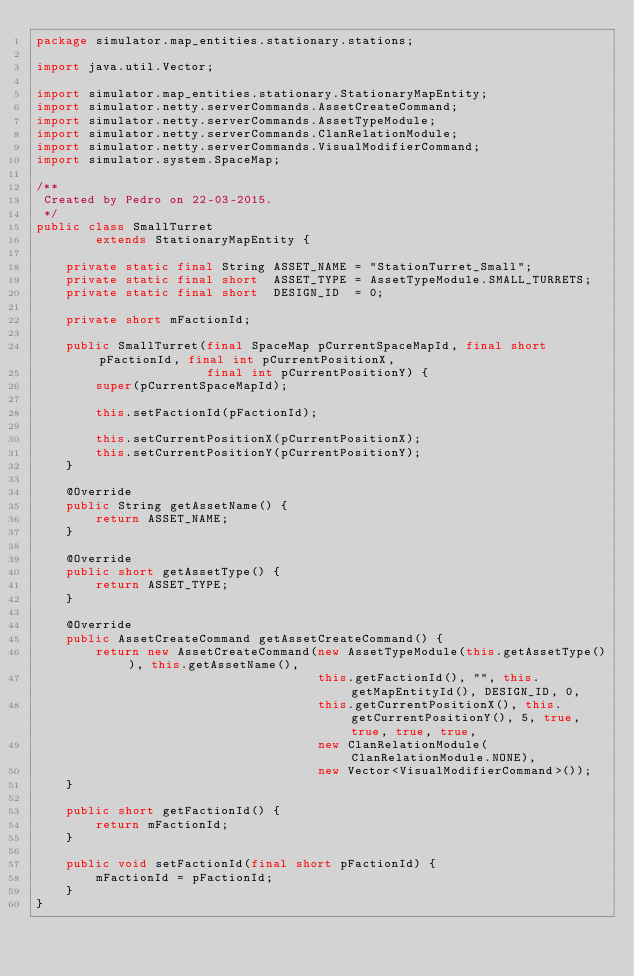<code> <loc_0><loc_0><loc_500><loc_500><_Java_>package simulator.map_entities.stationary.stations;

import java.util.Vector;

import simulator.map_entities.stationary.StationaryMapEntity;
import simulator.netty.serverCommands.AssetCreateCommand;
import simulator.netty.serverCommands.AssetTypeModule;
import simulator.netty.serverCommands.ClanRelationModule;
import simulator.netty.serverCommands.VisualModifierCommand;
import simulator.system.SpaceMap;

/**
 Created by Pedro on 22-03-2015.
 */
public class SmallTurret
        extends StationaryMapEntity {

    private static final String ASSET_NAME = "StationTurret_Small";
    private static final short  ASSET_TYPE = AssetTypeModule.SMALL_TURRETS;
    private static final short  DESIGN_ID  = 0;

    private short mFactionId;

    public SmallTurret(final SpaceMap pCurrentSpaceMapId, final short pFactionId, final int pCurrentPositionX,
                       final int pCurrentPositionY) {
        super(pCurrentSpaceMapId);

        this.setFactionId(pFactionId);

        this.setCurrentPositionX(pCurrentPositionX);
        this.setCurrentPositionY(pCurrentPositionY);
    }

    @Override
    public String getAssetName() {
        return ASSET_NAME;
    }

    @Override
    public short getAssetType() {
        return ASSET_TYPE;
    }

    @Override
    public AssetCreateCommand getAssetCreateCommand() {
        return new AssetCreateCommand(new AssetTypeModule(this.getAssetType()), this.getAssetName(),
                                      this.getFactionId(), "", this.getMapEntityId(), DESIGN_ID, 0,
                                      this.getCurrentPositionX(), this.getCurrentPositionY(), 5, true, true, true, true,
                                      new ClanRelationModule(ClanRelationModule.NONE),
                                      new Vector<VisualModifierCommand>());
    }

    public short getFactionId() {
        return mFactionId;
    }

    public void setFactionId(final short pFactionId) {
        mFactionId = pFactionId;
    }
}
</code> 